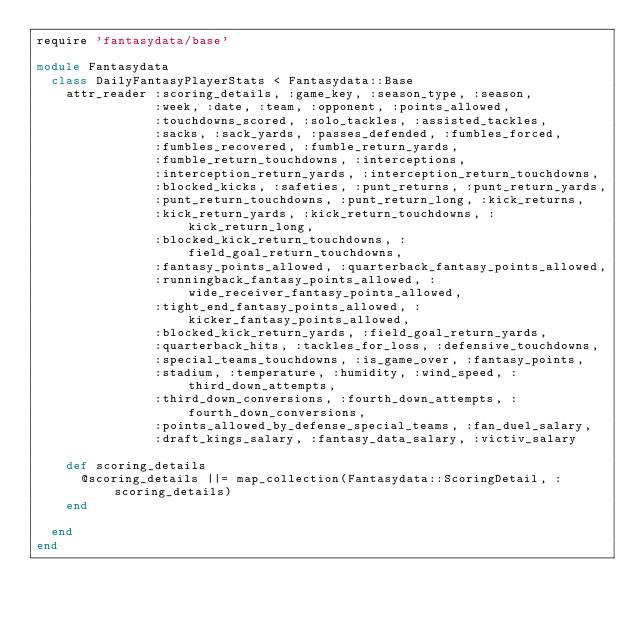<code> <loc_0><loc_0><loc_500><loc_500><_Ruby_>require 'fantasydata/base'

module Fantasydata
  class DailyFantasyPlayerStats < Fantasydata::Base
    attr_reader :scoring_details, :game_key, :season_type, :season, 
                :week, :date, :team, :opponent, :points_allowed, 
                :touchdowns_scored, :solo_tackles, :assisted_tackles, 
                :sacks, :sack_yards, :passes_defended, :fumbles_forced, 
                :fumbles_recovered, :fumble_return_yards, 
                :fumble_return_touchdowns, :interceptions, 
                :interception_return_yards, :interception_return_touchdowns, 
                :blocked_kicks, :safeties, :punt_returns, :punt_return_yards, 
                :punt_return_touchdowns, :punt_return_long, :kick_returns, 
                :kick_return_yards, :kick_return_touchdowns, :kick_return_long, 
                :blocked_kick_return_touchdowns, :field_goal_return_touchdowns, 
                :fantasy_points_allowed, :quarterback_fantasy_points_allowed, 
                :runningback_fantasy_points_allowed, :wide_receiver_fantasy_points_allowed, 
                :tight_end_fantasy_points_allowed, :kicker_fantasy_points_allowed, 
                :blocked_kick_return_yards, :field_goal_return_yards, 
                :quarterback_hits, :tackles_for_loss, :defensive_touchdowns, 
                :special_teams_touchdowns, :is_game_over, :fantasy_points, 
                :stadium, :temperature, :humidity, :wind_speed, :third_down_attempts, 
                :third_down_conversions, :fourth_down_attempts, :fourth_down_conversions, 
                :points_allowed_by_defense_special_teams, :fan_duel_salary, 
                :draft_kings_salary, :fantasy_data_salary, :victiv_salary
    
    def scoring_details
      @scoring_details ||= map_collection(Fantasydata::ScoringDetail, :scoring_details)
    end
    
  end
end



</code> 